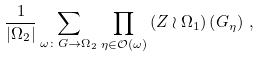<formula> <loc_0><loc_0><loc_500><loc_500>\frac { 1 } { \left | \Omega _ { 2 } \right | } \sum _ { \omega \colon G \rightarrow \Omega _ { 2 } } \prod _ { \eta \in \mathcal { O } \left ( \omega \right ) } \left ( Z \wr \Omega _ { 1 } \right ) \left ( G _ { \eta } \right ) \, ,</formula> 